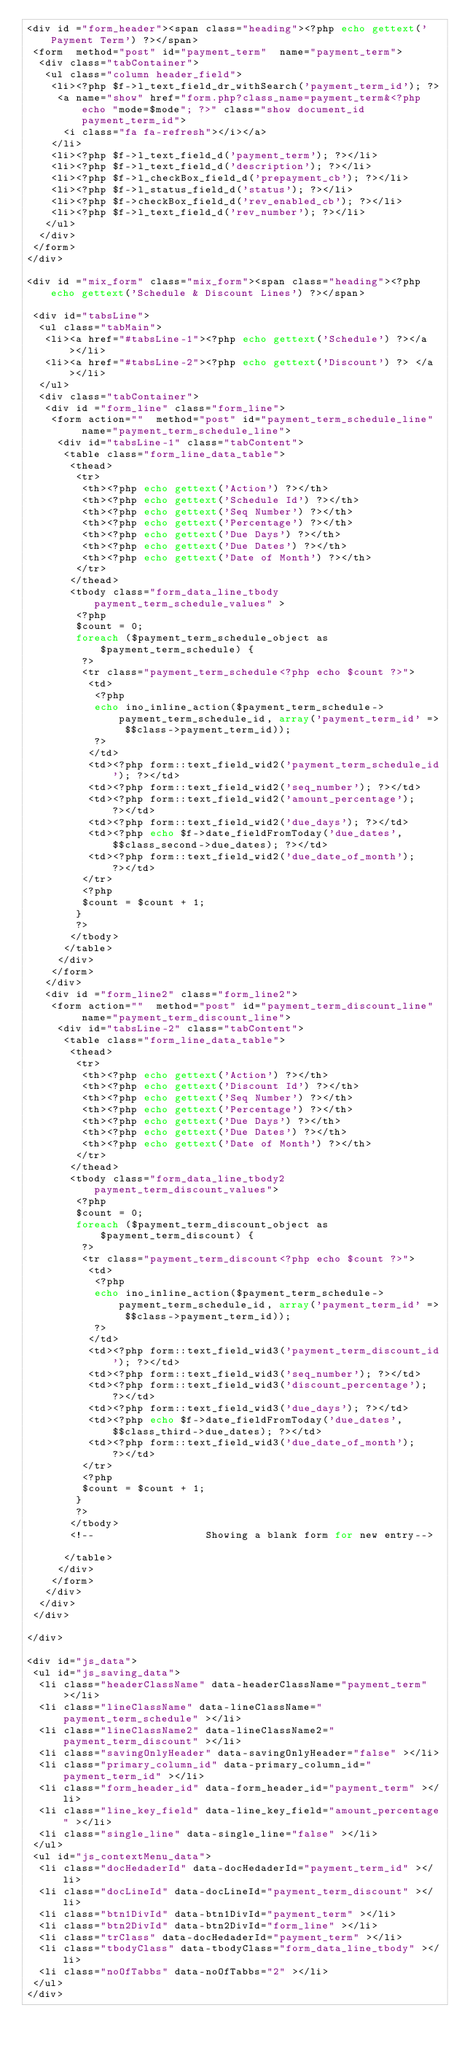Convert code to text. <code><loc_0><loc_0><loc_500><loc_500><_PHP_><div id ="form_header"><span class="heading"><?php echo gettext('Payment Term') ?></span>
 <form  method="post" id="payment_term"  name="payment_term">
  <div class="tabContainer">
   <ul class="column header_field">
    <li><?php $f->l_text_field_dr_withSearch('payment_term_id'); ?>
     <a name="show" href="form.php?class_name=payment_term&<?php echo "mode=$mode"; ?>" class="show document_id payment_term_id">
      <i class="fa fa-refresh"></i></a> 
    </li>
    <li><?php $f->l_text_field_d('payment_term'); ?></li>         
    <li><?php $f->l_text_field_d('description'); ?></li>         
    <li><?php $f->l_checkBox_field_d('prepayment_cb'); ?></li> 
    <li><?php $f->l_status_field_d('status'); ?></li>
    <li><?php $f->checkBox_field_d('rev_enabled_cb'); ?></li> 
    <li><?php $f->l_text_field_d('rev_number'); ?></li>         
   </ul>
  </div>
 </form>
</div>

<div id ="mix_form" class="mix_form"><span class="heading"><?php echo gettext('Schedule & Discount Lines') ?></span>

 <div id="tabsLine">
  <ul class="tabMain">
   <li><a href="#tabsLine-1"><?php echo gettext('Schedule') ?></a></li>
   <li><a href="#tabsLine-2"><?php echo gettext('Discount') ?> </a></li>
  </ul>
  <div class="tabContainer">
   <div id ="form_line" class="form_line">
    <form action=""  method="post" id="payment_term_schedule_line"  name="payment_term_schedule_line">
     <div id="tabsLine-1" class="tabContent">
      <table class="form_line_data_table">
       <thead> 
        <tr>
         <th><?php echo gettext('Action') ?></th>
         <th><?php echo gettext('Schedule Id') ?></th>
         <th><?php echo gettext('Seq Number') ?></th>
         <th><?php echo gettext('Percentage') ?></th>
         <th><?php echo gettext('Due Days') ?></th>
         <th><?php echo gettext('Due Dates') ?></th>
         <th><?php echo gettext('Date of Month') ?></th>
        </tr>
       </thead>
       <tbody class="form_data_line_tbody payment_term_schedule_values" >
        <?php
        $count = 0;
        foreach ($payment_term_schedule_object as $payment_term_schedule) {
         ?>         
         <tr class="payment_term_schedule<?php echo $count ?>">
          <td>
           <?php
           echo ino_inline_action($payment_term_schedule->payment_term_schedule_id, array('payment_term_id' => $$class->payment_term_id));
           ?>
          </td>
          <td><?php form::text_field_wid2('payment_term_schedule_id'); ?></td>
          <td><?php form::text_field_wid2('seq_number'); ?></td>
          <td><?php form::text_field_wid2('amount_percentage'); ?></td>
          <td><?php form::text_field_wid2('due_days'); ?></td>
          <td><?php echo $f->date_fieldFromToday('due_dates', $$class_second->due_dates); ?></td>
          <td><?php form::text_field_wid2('due_date_of_month'); ?></td>
         </tr>
         <?php
         $count = $count + 1;
        }
        ?>
       </tbody>
      </table>
     </div>
    </form>
   </div>
   <div id ="form_line2" class="form_line2">
    <form action=""  method="post" id="payment_term_discount_line"  name="payment_term_discount_line">
     <div id="tabsLine-2" class="tabContent">
      <table class="form_line_data_table">
       <thead> 
        <tr>
         <th><?php echo gettext('Action') ?></th>
         <th><?php echo gettext('Discount Id') ?></th>
         <th><?php echo gettext('Seq Number') ?></th>
         <th><?php echo gettext('Percentage') ?></th>
         <th><?php echo gettext('Due Days') ?></th>
         <th><?php echo gettext('Due Dates') ?></th>
         <th><?php echo gettext('Date of Month') ?></th>
        </tr>
       </thead>
       <tbody class="form_data_line_tbody2 payment_term_discount_values">
        <?php
        $count = 0;
        foreach ($payment_term_discount_object as $payment_term_discount) {
         ?>         
         <tr class="payment_term_discount<?php echo $count ?>">
          <td>
           <?php
           echo ino_inline_action($payment_term_schedule->payment_term_schedule_id, array('payment_term_id' => $$class->payment_term_id));
           ?>
          </td>
          <td><?php form::text_field_wid3('payment_term_discount_id'); ?></td>
          <td><?php form::text_field_wid3('seq_number'); ?></td>
          <td><?php form::text_field_wid3('discount_percentage'); ?></td>
          <td><?php form::text_field_wid3('due_days'); ?></td>
          <td><?php echo $f->date_fieldFromToday('due_dates', $$class_third->due_dates); ?></td>
          <td><?php form::text_field_wid3('due_date_of_month'); ?></td>
         </tr>
         <?php
         $count = $count + 1;
        }
        ?>
       </tbody>
       <!--                  Showing a blank form for new entry-->

      </table>
     </div>
    </form>
   </div>
  </div>
 </div>

</div>

<div id="js_data">
 <ul id="js_saving_data">
  <li class="headerClassName" data-headerClassName="payment_term" ></li>
  <li class="lineClassName" data-lineClassName="payment_term_schedule" ></li>
  <li class="lineClassName2" data-lineClassName2="payment_term_discount" ></li>
  <li class="savingOnlyHeader" data-savingOnlyHeader="false" ></li>
  <li class="primary_column_id" data-primary_column_id="payment_term_id" ></li>
  <li class="form_header_id" data-form_header_id="payment_term" ></li>
  <li class="line_key_field" data-line_key_field="amount_percentage" ></li>
  <li class="single_line" data-single_line="false" ></li>
 </ul>
 <ul id="js_contextMenu_data">
  <li class="docHedaderId" data-docHedaderId="payment_term_id" ></li>
  <li class="docLineId" data-docLineId="payment_term_discount" ></li>
  <li class="btn1DivId" data-btn1DivId="payment_term" ></li>
  <li class="btn2DivId" data-btn2DivId="form_line" ></li>
  <li class="trClass" data-docHedaderId="payment_term" ></li>
  <li class="tbodyClass" data-tbodyClass="form_data_line_tbody" ></li>
  <li class="noOfTabbs" data-noOfTabbs="2" ></li>
 </ul>
</div></code> 